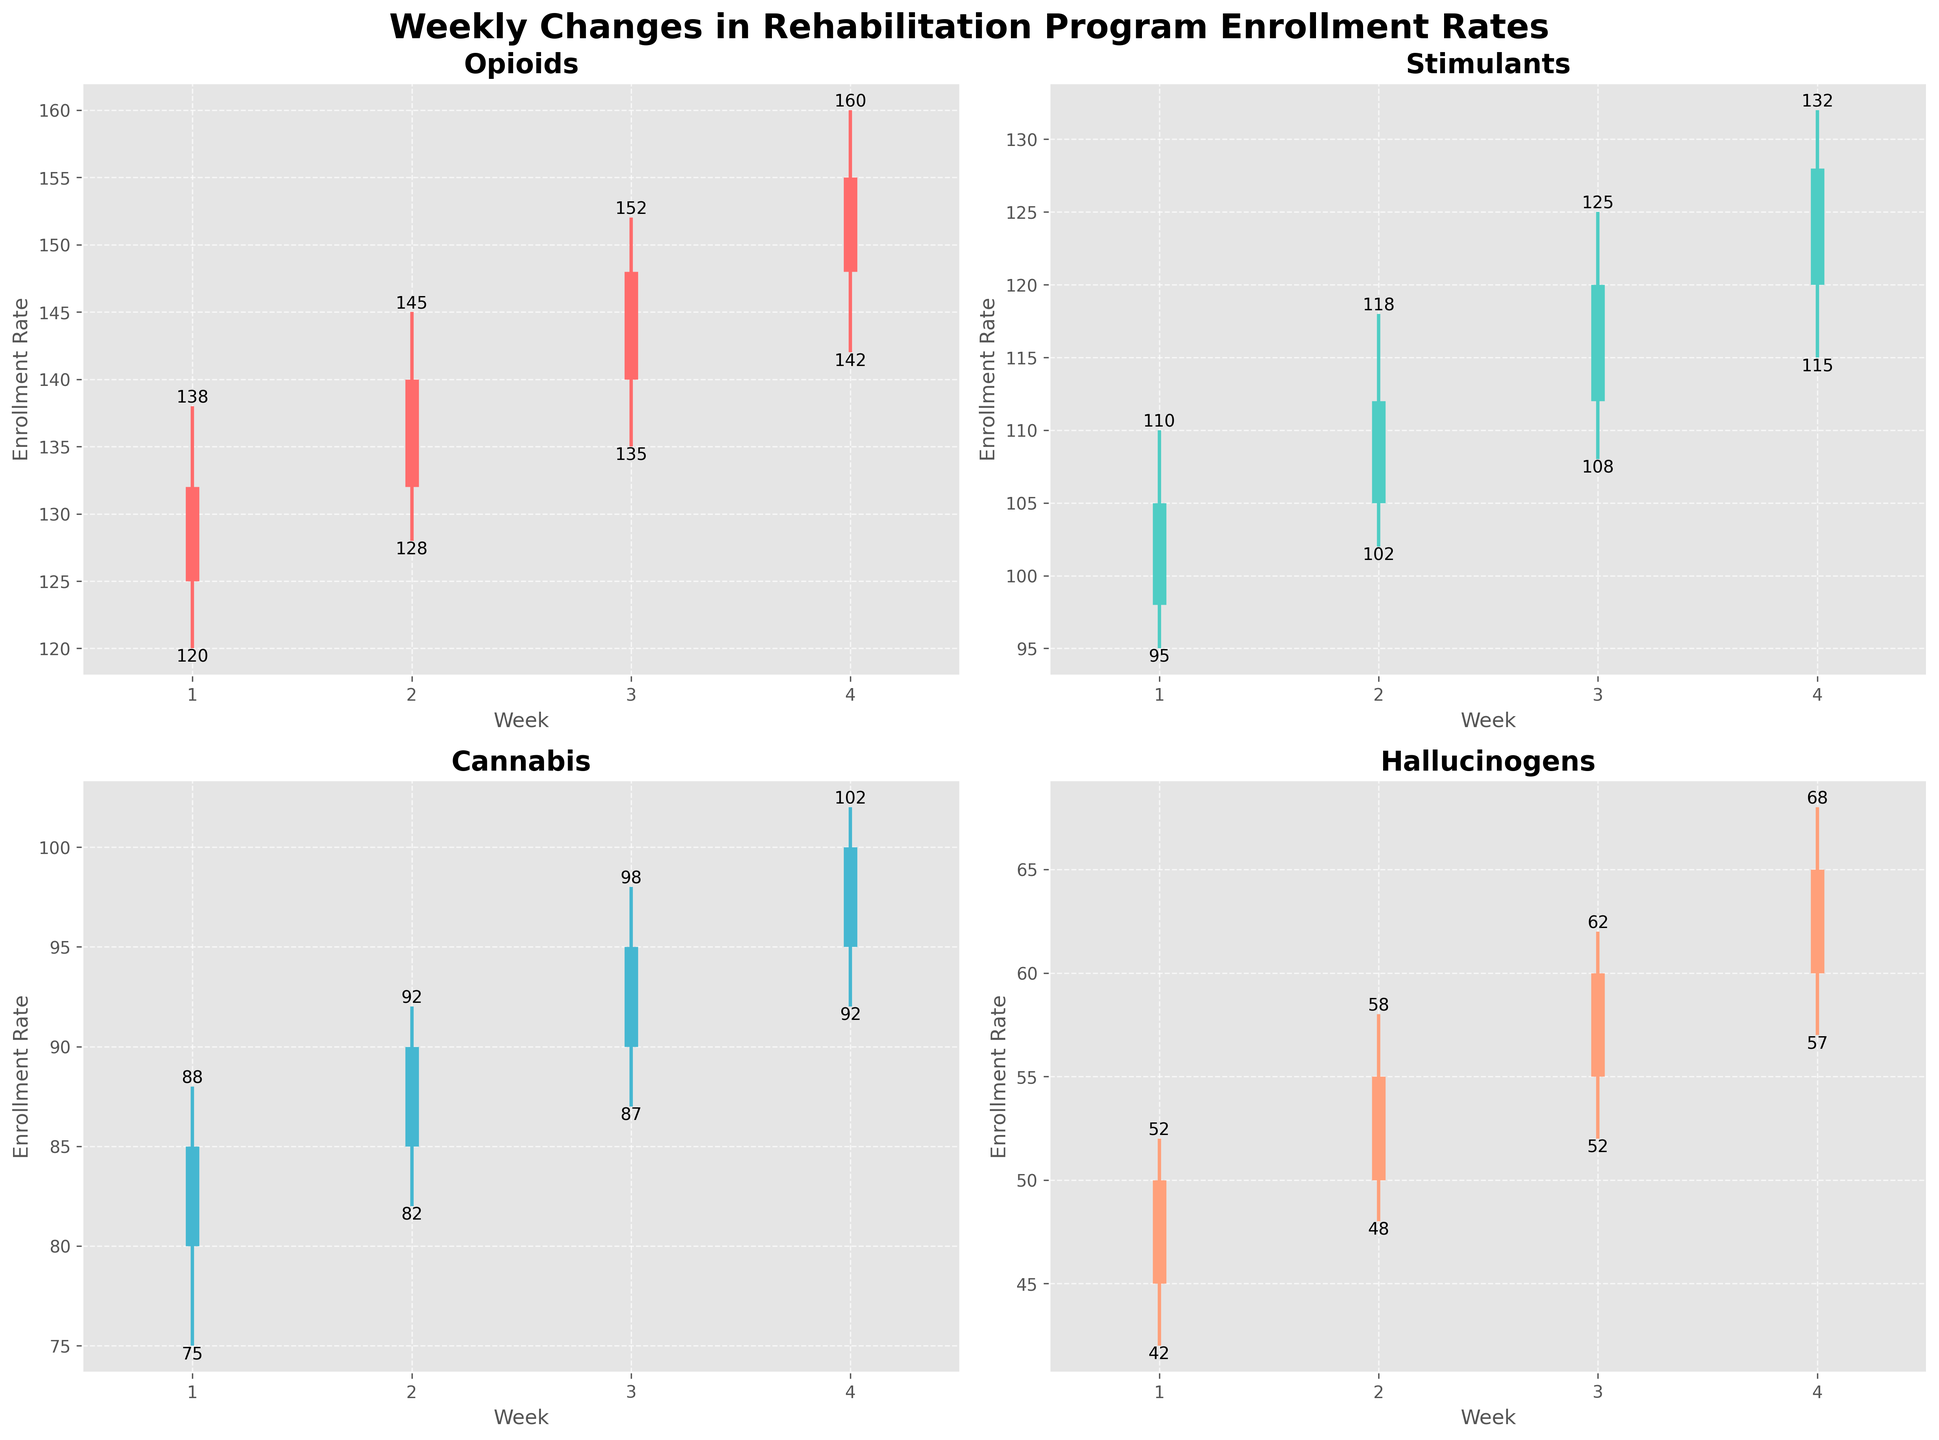What's the title of the figure? The title is written at the top of the figure in large, bold font. It encapsulates the overall theme of the data being represented.
Answer: Weekly Changes in Rehabilitation Program Enrollment Rates How many drug categories are displayed in the figure? There are separate plots for each drug category in the subplots. By counting the titles of each subplot, one can determine the number of different categories presented.
Answer: Four Which drug category shows the highest close value in Week 4? To find this, we look at the final week (Week 4) for each drug category and compare the close values.
Answer: Opioids What is the difference between the high and low values for Stimulants in Week 2? For Week 2, locate the high and low values for Stimulants. Subtract the low value from the high value to find the difference.
Answer: 16 Which drug category experienced the smallest range (difference between high and low) in Week 1? Check the range (high - low) for each category in Week 1 and compare them to find the minimum.
Answer: Cannabis What is the average close value of Cannabis over the four weeks? Add the close values of Cannabis for each week and divide by the number of weeks.
Answer: 92.5 Did the Close value for Hallucinogens increase or decrease from Week 1 to Week 2? Compare the close values of Hallucinogens for Week 1 and Week 2 to determine the change.
Answer: Increase Which drug category shows the greatest increase in close value from Week 1 to Week 4? Calculate the increase for each category from Week 1 to Week 4 and identify the greatest change.
Answer: Opioids Between which weeks does Cannabis show the greatest weekly increase in close value? Examine the weekly close values for Cannabis and calculate the differences, then find the week pair with the highest difference.
Answer: Week 1 to Week 2 What was the open value for Opioids in Week 2? Locate the subplot for Opioids and identify the open value in Week 2.
Answer: 132 